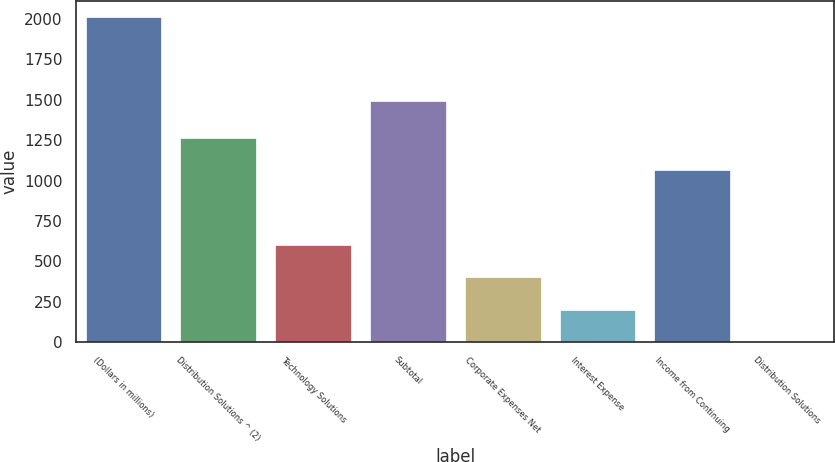Convert chart. <chart><loc_0><loc_0><loc_500><loc_500><bar_chart><fcel>(Dollars in millions)<fcel>Distribution Solutions ^ (2)<fcel>Technology Solutions<fcel>Subtotal<fcel>Corporate Expenses Net<fcel>Interest Expense<fcel>Income from Continuing<fcel>Distribution Solutions<nl><fcel>2009<fcel>1264.79<fcel>603.49<fcel>1492<fcel>402.7<fcel>201.91<fcel>1064<fcel>1.12<nl></chart> 